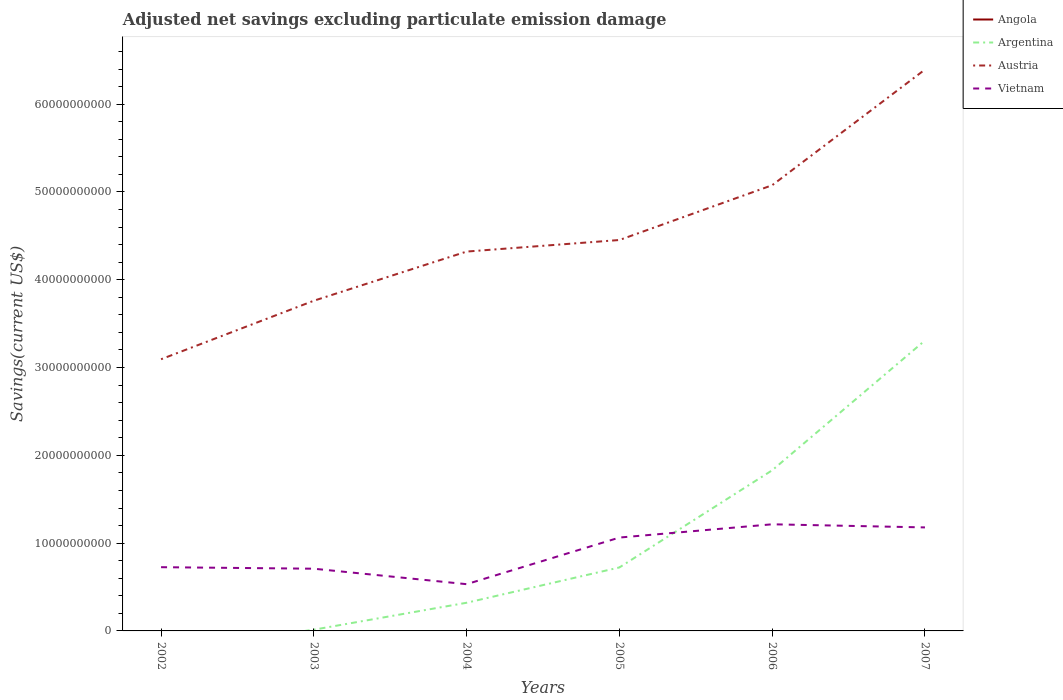Across all years, what is the maximum adjusted net savings in Austria?
Offer a terse response. 3.09e+1. What is the total adjusted net savings in Austria in the graph?
Your response must be concise. -1.94e+1. What is the difference between the highest and the second highest adjusted net savings in Vietnam?
Offer a terse response. 6.82e+09. What is the difference between the highest and the lowest adjusted net savings in Argentina?
Your response must be concise. 2. What is the difference between two consecutive major ticks on the Y-axis?
Offer a terse response. 1.00e+1. Does the graph contain any zero values?
Your answer should be very brief. Yes. Does the graph contain grids?
Offer a terse response. No. Where does the legend appear in the graph?
Your answer should be very brief. Top right. How many legend labels are there?
Provide a succinct answer. 4. What is the title of the graph?
Offer a terse response. Adjusted net savings excluding particulate emission damage. Does "Central African Republic" appear as one of the legend labels in the graph?
Give a very brief answer. No. What is the label or title of the Y-axis?
Keep it short and to the point. Savings(current US$). What is the Savings(current US$) in Angola in 2002?
Ensure brevity in your answer.  0. What is the Savings(current US$) in Argentina in 2002?
Make the answer very short. 0. What is the Savings(current US$) of Austria in 2002?
Provide a succinct answer. 3.09e+1. What is the Savings(current US$) in Vietnam in 2002?
Your response must be concise. 7.26e+09. What is the Savings(current US$) of Argentina in 2003?
Ensure brevity in your answer.  1.39e+08. What is the Savings(current US$) of Austria in 2003?
Give a very brief answer. 3.76e+1. What is the Savings(current US$) of Vietnam in 2003?
Offer a terse response. 7.09e+09. What is the Savings(current US$) of Argentina in 2004?
Your response must be concise. 3.21e+09. What is the Savings(current US$) of Austria in 2004?
Keep it short and to the point. 4.32e+1. What is the Savings(current US$) in Vietnam in 2004?
Offer a terse response. 5.32e+09. What is the Savings(current US$) of Argentina in 2005?
Your answer should be very brief. 7.23e+09. What is the Savings(current US$) of Austria in 2005?
Offer a terse response. 4.45e+1. What is the Savings(current US$) in Vietnam in 2005?
Your response must be concise. 1.06e+1. What is the Savings(current US$) in Argentina in 2006?
Give a very brief answer. 1.83e+1. What is the Savings(current US$) in Austria in 2006?
Give a very brief answer. 5.08e+1. What is the Savings(current US$) in Vietnam in 2006?
Provide a short and direct response. 1.21e+1. What is the Savings(current US$) of Angola in 2007?
Provide a short and direct response. 0. What is the Savings(current US$) of Argentina in 2007?
Give a very brief answer. 3.31e+1. What is the Savings(current US$) of Austria in 2007?
Give a very brief answer. 6.39e+1. What is the Savings(current US$) in Vietnam in 2007?
Keep it short and to the point. 1.18e+1. Across all years, what is the maximum Savings(current US$) in Argentina?
Your response must be concise. 3.31e+1. Across all years, what is the maximum Savings(current US$) in Austria?
Provide a succinct answer. 6.39e+1. Across all years, what is the maximum Savings(current US$) in Vietnam?
Make the answer very short. 1.21e+1. Across all years, what is the minimum Savings(current US$) of Argentina?
Your answer should be very brief. 0. Across all years, what is the minimum Savings(current US$) of Austria?
Provide a succinct answer. 3.09e+1. Across all years, what is the minimum Savings(current US$) in Vietnam?
Offer a terse response. 5.32e+09. What is the total Savings(current US$) in Argentina in the graph?
Keep it short and to the point. 6.20e+1. What is the total Savings(current US$) in Austria in the graph?
Provide a short and direct response. 2.71e+11. What is the total Savings(current US$) of Vietnam in the graph?
Make the answer very short. 5.42e+1. What is the difference between the Savings(current US$) in Austria in 2002 and that in 2003?
Provide a short and direct response. -6.67e+09. What is the difference between the Savings(current US$) in Vietnam in 2002 and that in 2003?
Provide a succinct answer. 1.73e+08. What is the difference between the Savings(current US$) of Austria in 2002 and that in 2004?
Provide a succinct answer. -1.23e+1. What is the difference between the Savings(current US$) in Vietnam in 2002 and that in 2004?
Your answer should be very brief. 1.94e+09. What is the difference between the Savings(current US$) in Austria in 2002 and that in 2005?
Your answer should be compact. -1.36e+1. What is the difference between the Savings(current US$) in Vietnam in 2002 and that in 2005?
Make the answer very short. -3.37e+09. What is the difference between the Savings(current US$) in Austria in 2002 and that in 2006?
Give a very brief answer. -1.98e+1. What is the difference between the Savings(current US$) of Vietnam in 2002 and that in 2006?
Your answer should be very brief. -4.89e+09. What is the difference between the Savings(current US$) of Austria in 2002 and that in 2007?
Keep it short and to the point. -3.30e+1. What is the difference between the Savings(current US$) of Vietnam in 2002 and that in 2007?
Your response must be concise. -4.53e+09. What is the difference between the Savings(current US$) in Argentina in 2003 and that in 2004?
Ensure brevity in your answer.  -3.07e+09. What is the difference between the Savings(current US$) of Austria in 2003 and that in 2004?
Give a very brief answer. -5.60e+09. What is the difference between the Savings(current US$) of Vietnam in 2003 and that in 2004?
Give a very brief answer. 1.76e+09. What is the difference between the Savings(current US$) in Argentina in 2003 and that in 2005?
Your response must be concise. -7.09e+09. What is the difference between the Savings(current US$) of Austria in 2003 and that in 2005?
Your answer should be compact. -6.91e+09. What is the difference between the Savings(current US$) of Vietnam in 2003 and that in 2005?
Provide a succinct answer. -3.55e+09. What is the difference between the Savings(current US$) of Argentina in 2003 and that in 2006?
Ensure brevity in your answer.  -1.82e+1. What is the difference between the Savings(current US$) in Austria in 2003 and that in 2006?
Offer a terse response. -1.32e+1. What is the difference between the Savings(current US$) of Vietnam in 2003 and that in 2006?
Make the answer very short. -5.06e+09. What is the difference between the Savings(current US$) in Argentina in 2003 and that in 2007?
Give a very brief answer. -3.29e+1. What is the difference between the Savings(current US$) in Austria in 2003 and that in 2007?
Your answer should be very brief. -2.63e+1. What is the difference between the Savings(current US$) in Vietnam in 2003 and that in 2007?
Your answer should be compact. -4.70e+09. What is the difference between the Savings(current US$) of Argentina in 2004 and that in 2005?
Keep it short and to the point. -4.02e+09. What is the difference between the Savings(current US$) of Austria in 2004 and that in 2005?
Your answer should be compact. -1.32e+09. What is the difference between the Savings(current US$) of Vietnam in 2004 and that in 2005?
Provide a short and direct response. -5.31e+09. What is the difference between the Savings(current US$) of Argentina in 2004 and that in 2006?
Offer a very short reply. -1.51e+1. What is the difference between the Savings(current US$) of Austria in 2004 and that in 2006?
Ensure brevity in your answer.  -7.56e+09. What is the difference between the Savings(current US$) in Vietnam in 2004 and that in 2006?
Ensure brevity in your answer.  -6.82e+09. What is the difference between the Savings(current US$) in Argentina in 2004 and that in 2007?
Your answer should be very brief. -2.99e+1. What is the difference between the Savings(current US$) in Austria in 2004 and that in 2007?
Your answer should be compact. -2.07e+1. What is the difference between the Savings(current US$) in Vietnam in 2004 and that in 2007?
Your answer should be very brief. -6.47e+09. What is the difference between the Savings(current US$) in Argentina in 2005 and that in 2006?
Give a very brief answer. -1.11e+1. What is the difference between the Savings(current US$) in Austria in 2005 and that in 2006?
Offer a terse response. -6.24e+09. What is the difference between the Savings(current US$) of Vietnam in 2005 and that in 2006?
Offer a very short reply. -1.51e+09. What is the difference between the Savings(current US$) of Argentina in 2005 and that in 2007?
Offer a terse response. -2.59e+1. What is the difference between the Savings(current US$) in Austria in 2005 and that in 2007?
Offer a terse response. -1.94e+1. What is the difference between the Savings(current US$) of Vietnam in 2005 and that in 2007?
Offer a very short reply. -1.16e+09. What is the difference between the Savings(current US$) of Argentina in 2006 and that in 2007?
Your answer should be compact. -1.48e+1. What is the difference between the Savings(current US$) in Austria in 2006 and that in 2007?
Provide a succinct answer. -1.32e+1. What is the difference between the Savings(current US$) in Vietnam in 2006 and that in 2007?
Provide a succinct answer. 3.55e+08. What is the difference between the Savings(current US$) in Austria in 2002 and the Savings(current US$) in Vietnam in 2003?
Make the answer very short. 2.39e+1. What is the difference between the Savings(current US$) of Austria in 2002 and the Savings(current US$) of Vietnam in 2004?
Ensure brevity in your answer.  2.56e+1. What is the difference between the Savings(current US$) of Austria in 2002 and the Savings(current US$) of Vietnam in 2005?
Give a very brief answer. 2.03e+1. What is the difference between the Savings(current US$) in Austria in 2002 and the Savings(current US$) in Vietnam in 2006?
Make the answer very short. 1.88e+1. What is the difference between the Savings(current US$) of Austria in 2002 and the Savings(current US$) of Vietnam in 2007?
Provide a succinct answer. 1.92e+1. What is the difference between the Savings(current US$) in Argentina in 2003 and the Savings(current US$) in Austria in 2004?
Provide a short and direct response. -4.31e+1. What is the difference between the Savings(current US$) of Argentina in 2003 and the Savings(current US$) of Vietnam in 2004?
Offer a terse response. -5.19e+09. What is the difference between the Savings(current US$) in Austria in 2003 and the Savings(current US$) in Vietnam in 2004?
Offer a very short reply. 3.23e+1. What is the difference between the Savings(current US$) in Argentina in 2003 and the Savings(current US$) in Austria in 2005?
Your response must be concise. -4.44e+1. What is the difference between the Savings(current US$) of Argentina in 2003 and the Savings(current US$) of Vietnam in 2005?
Your response must be concise. -1.05e+1. What is the difference between the Savings(current US$) of Austria in 2003 and the Savings(current US$) of Vietnam in 2005?
Provide a succinct answer. 2.70e+1. What is the difference between the Savings(current US$) of Argentina in 2003 and the Savings(current US$) of Austria in 2006?
Your response must be concise. -5.06e+1. What is the difference between the Savings(current US$) of Argentina in 2003 and the Savings(current US$) of Vietnam in 2006?
Ensure brevity in your answer.  -1.20e+1. What is the difference between the Savings(current US$) in Austria in 2003 and the Savings(current US$) in Vietnam in 2006?
Offer a terse response. 2.55e+1. What is the difference between the Savings(current US$) of Argentina in 2003 and the Savings(current US$) of Austria in 2007?
Offer a terse response. -6.38e+1. What is the difference between the Savings(current US$) in Argentina in 2003 and the Savings(current US$) in Vietnam in 2007?
Ensure brevity in your answer.  -1.17e+1. What is the difference between the Savings(current US$) of Austria in 2003 and the Savings(current US$) of Vietnam in 2007?
Ensure brevity in your answer.  2.58e+1. What is the difference between the Savings(current US$) in Argentina in 2004 and the Savings(current US$) in Austria in 2005?
Your answer should be compact. -4.13e+1. What is the difference between the Savings(current US$) of Argentina in 2004 and the Savings(current US$) of Vietnam in 2005?
Provide a short and direct response. -7.43e+09. What is the difference between the Savings(current US$) in Austria in 2004 and the Savings(current US$) in Vietnam in 2005?
Make the answer very short. 3.26e+1. What is the difference between the Savings(current US$) in Argentina in 2004 and the Savings(current US$) in Austria in 2006?
Offer a very short reply. -4.76e+1. What is the difference between the Savings(current US$) in Argentina in 2004 and the Savings(current US$) in Vietnam in 2006?
Make the answer very short. -8.94e+09. What is the difference between the Savings(current US$) in Austria in 2004 and the Savings(current US$) in Vietnam in 2006?
Your answer should be very brief. 3.11e+1. What is the difference between the Savings(current US$) of Argentina in 2004 and the Savings(current US$) of Austria in 2007?
Make the answer very short. -6.07e+1. What is the difference between the Savings(current US$) in Argentina in 2004 and the Savings(current US$) in Vietnam in 2007?
Offer a very short reply. -8.58e+09. What is the difference between the Savings(current US$) in Austria in 2004 and the Savings(current US$) in Vietnam in 2007?
Your response must be concise. 3.14e+1. What is the difference between the Savings(current US$) in Argentina in 2005 and the Savings(current US$) in Austria in 2006?
Ensure brevity in your answer.  -4.35e+1. What is the difference between the Savings(current US$) of Argentina in 2005 and the Savings(current US$) of Vietnam in 2006?
Offer a terse response. -4.92e+09. What is the difference between the Savings(current US$) of Austria in 2005 and the Savings(current US$) of Vietnam in 2006?
Offer a very short reply. 3.24e+1. What is the difference between the Savings(current US$) of Argentina in 2005 and the Savings(current US$) of Austria in 2007?
Provide a succinct answer. -5.67e+1. What is the difference between the Savings(current US$) of Argentina in 2005 and the Savings(current US$) of Vietnam in 2007?
Your answer should be very brief. -4.56e+09. What is the difference between the Savings(current US$) of Austria in 2005 and the Savings(current US$) of Vietnam in 2007?
Your answer should be very brief. 3.27e+1. What is the difference between the Savings(current US$) in Argentina in 2006 and the Savings(current US$) in Austria in 2007?
Ensure brevity in your answer.  -4.56e+1. What is the difference between the Savings(current US$) of Argentina in 2006 and the Savings(current US$) of Vietnam in 2007?
Offer a very short reply. 6.51e+09. What is the difference between the Savings(current US$) of Austria in 2006 and the Savings(current US$) of Vietnam in 2007?
Your response must be concise. 3.90e+1. What is the average Savings(current US$) of Angola per year?
Provide a short and direct response. 0. What is the average Savings(current US$) in Argentina per year?
Your answer should be compact. 1.03e+1. What is the average Savings(current US$) in Austria per year?
Make the answer very short. 4.52e+1. What is the average Savings(current US$) of Vietnam per year?
Provide a succinct answer. 9.04e+09. In the year 2002, what is the difference between the Savings(current US$) of Austria and Savings(current US$) of Vietnam?
Provide a succinct answer. 2.37e+1. In the year 2003, what is the difference between the Savings(current US$) of Argentina and Savings(current US$) of Austria?
Your response must be concise. -3.75e+1. In the year 2003, what is the difference between the Savings(current US$) of Argentina and Savings(current US$) of Vietnam?
Provide a succinct answer. -6.95e+09. In the year 2003, what is the difference between the Savings(current US$) in Austria and Savings(current US$) in Vietnam?
Offer a very short reply. 3.05e+1. In the year 2004, what is the difference between the Savings(current US$) of Argentina and Savings(current US$) of Austria?
Provide a succinct answer. -4.00e+1. In the year 2004, what is the difference between the Savings(current US$) in Argentina and Savings(current US$) in Vietnam?
Provide a short and direct response. -2.12e+09. In the year 2004, what is the difference between the Savings(current US$) in Austria and Savings(current US$) in Vietnam?
Provide a short and direct response. 3.79e+1. In the year 2005, what is the difference between the Savings(current US$) in Argentina and Savings(current US$) in Austria?
Provide a succinct answer. -3.73e+1. In the year 2005, what is the difference between the Savings(current US$) in Argentina and Savings(current US$) in Vietnam?
Ensure brevity in your answer.  -3.40e+09. In the year 2005, what is the difference between the Savings(current US$) of Austria and Savings(current US$) of Vietnam?
Keep it short and to the point. 3.39e+1. In the year 2006, what is the difference between the Savings(current US$) of Argentina and Savings(current US$) of Austria?
Make the answer very short. -3.25e+1. In the year 2006, what is the difference between the Savings(current US$) in Argentina and Savings(current US$) in Vietnam?
Make the answer very short. 6.15e+09. In the year 2006, what is the difference between the Savings(current US$) of Austria and Savings(current US$) of Vietnam?
Provide a succinct answer. 3.86e+1. In the year 2007, what is the difference between the Savings(current US$) of Argentina and Savings(current US$) of Austria?
Your answer should be compact. -3.09e+1. In the year 2007, what is the difference between the Savings(current US$) of Argentina and Savings(current US$) of Vietnam?
Provide a succinct answer. 2.13e+1. In the year 2007, what is the difference between the Savings(current US$) of Austria and Savings(current US$) of Vietnam?
Provide a succinct answer. 5.22e+1. What is the ratio of the Savings(current US$) of Austria in 2002 to that in 2003?
Provide a short and direct response. 0.82. What is the ratio of the Savings(current US$) in Vietnam in 2002 to that in 2003?
Ensure brevity in your answer.  1.02. What is the ratio of the Savings(current US$) in Austria in 2002 to that in 2004?
Your response must be concise. 0.72. What is the ratio of the Savings(current US$) of Vietnam in 2002 to that in 2004?
Offer a terse response. 1.36. What is the ratio of the Savings(current US$) of Austria in 2002 to that in 2005?
Your response must be concise. 0.69. What is the ratio of the Savings(current US$) of Vietnam in 2002 to that in 2005?
Your answer should be very brief. 0.68. What is the ratio of the Savings(current US$) in Austria in 2002 to that in 2006?
Make the answer very short. 0.61. What is the ratio of the Savings(current US$) of Vietnam in 2002 to that in 2006?
Your response must be concise. 0.6. What is the ratio of the Savings(current US$) in Austria in 2002 to that in 2007?
Give a very brief answer. 0.48. What is the ratio of the Savings(current US$) of Vietnam in 2002 to that in 2007?
Your answer should be very brief. 0.62. What is the ratio of the Savings(current US$) in Argentina in 2003 to that in 2004?
Ensure brevity in your answer.  0.04. What is the ratio of the Savings(current US$) of Austria in 2003 to that in 2004?
Your answer should be very brief. 0.87. What is the ratio of the Savings(current US$) in Vietnam in 2003 to that in 2004?
Your response must be concise. 1.33. What is the ratio of the Savings(current US$) in Argentina in 2003 to that in 2005?
Your answer should be very brief. 0.02. What is the ratio of the Savings(current US$) of Austria in 2003 to that in 2005?
Your answer should be very brief. 0.84. What is the ratio of the Savings(current US$) in Vietnam in 2003 to that in 2005?
Offer a very short reply. 0.67. What is the ratio of the Savings(current US$) of Argentina in 2003 to that in 2006?
Your answer should be compact. 0.01. What is the ratio of the Savings(current US$) of Austria in 2003 to that in 2006?
Give a very brief answer. 0.74. What is the ratio of the Savings(current US$) in Vietnam in 2003 to that in 2006?
Keep it short and to the point. 0.58. What is the ratio of the Savings(current US$) of Argentina in 2003 to that in 2007?
Offer a very short reply. 0. What is the ratio of the Savings(current US$) in Austria in 2003 to that in 2007?
Offer a very short reply. 0.59. What is the ratio of the Savings(current US$) of Vietnam in 2003 to that in 2007?
Give a very brief answer. 0.6. What is the ratio of the Savings(current US$) of Argentina in 2004 to that in 2005?
Provide a short and direct response. 0.44. What is the ratio of the Savings(current US$) in Austria in 2004 to that in 2005?
Ensure brevity in your answer.  0.97. What is the ratio of the Savings(current US$) of Vietnam in 2004 to that in 2005?
Make the answer very short. 0.5. What is the ratio of the Savings(current US$) of Argentina in 2004 to that in 2006?
Offer a very short reply. 0.18. What is the ratio of the Savings(current US$) of Austria in 2004 to that in 2006?
Provide a short and direct response. 0.85. What is the ratio of the Savings(current US$) of Vietnam in 2004 to that in 2006?
Your answer should be very brief. 0.44. What is the ratio of the Savings(current US$) of Argentina in 2004 to that in 2007?
Your answer should be compact. 0.1. What is the ratio of the Savings(current US$) in Austria in 2004 to that in 2007?
Offer a terse response. 0.68. What is the ratio of the Savings(current US$) in Vietnam in 2004 to that in 2007?
Keep it short and to the point. 0.45. What is the ratio of the Savings(current US$) of Argentina in 2005 to that in 2006?
Make the answer very short. 0.4. What is the ratio of the Savings(current US$) in Austria in 2005 to that in 2006?
Give a very brief answer. 0.88. What is the ratio of the Savings(current US$) of Vietnam in 2005 to that in 2006?
Offer a terse response. 0.88. What is the ratio of the Savings(current US$) of Argentina in 2005 to that in 2007?
Your answer should be very brief. 0.22. What is the ratio of the Savings(current US$) in Austria in 2005 to that in 2007?
Ensure brevity in your answer.  0.7. What is the ratio of the Savings(current US$) of Vietnam in 2005 to that in 2007?
Keep it short and to the point. 0.9. What is the ratio of the Savings(current US$) in Argentina in 2006 to that in 2007?
Your answer should be compact. 0.55. What is the ratio of the Savings(current US$) of Austria in 2006 to that in 2007?
Your answer should be very brief. 0.79. What is the ratio of the Savings(current US$) in Vietnam in 2006 to that in 2007?
Offer a very short reply. 1.03. What is the difference between the highest and the second highest Savings(current US$) of Argentina?
Give a very brief answer. 1.48e+1. What is the difference between the highest and the second highest Savings(current US$) in Austria?
Keep it short and to the point. 1.32e+1. What is the difference between the highest and the second highest Savings(current US$) of Vietnam?
Your answer should be compact. 3.55e+08. What is the difference between the highest and the lowest Savings(current US$) in Argentina?
Give a very brief answer. 3.31e+1. What is the difference between the highest and the lowest Savings(current US$) in Austria?
Provide a succinct answer. 3.30e+1. What is the difference between the highest and the lowest Savings(current US$) of Vietnam?
Keep it short and to the point. 6.82e+09. 